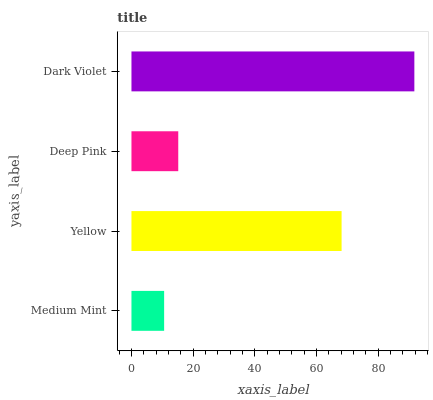Is Medium Mint the minimum?
Answer yes or no. Yes. Is Dark Violet the maximum?
Answer yes or no. Yes. Is Yellow the minimum?
Answer yes or no. No. Is Yellow the maximum?
Answer yes or no. No. Is Yellow greater than Medium Mint?
Answer yes or no. Yes. Is Medium Mint less than Yellow?
Answer yes or no. Yes. Is Medium Mint greater than Yellow?
Answer yes or no. No. Is Yellow less than Medium Mint?
Answer yes or no. No. Is Yellow the high median?
Answer yes or no. Yes. Is Deep Pink the low median?
Answer yes or no. Yes. Is Dark Violet the high median?
Answer yes or no. No. Is Yellow the low median?
Answer yes or no. No. 